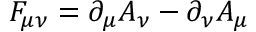Convert formula to latex. <formula><loc_0><loc_0><loc_500><loc_500>F _ { \mu \nu } = \partial _ { \mu } A _ { \nu } - \partial _ { \nu } A _ { \mu }</formula> 